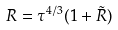Convert formula to latex. <formula><loc_0><loc_0><loc_500><loc_500>R = \tau ^ { 4 / 3 } ( 1 + \tilde { R } )</formula> 